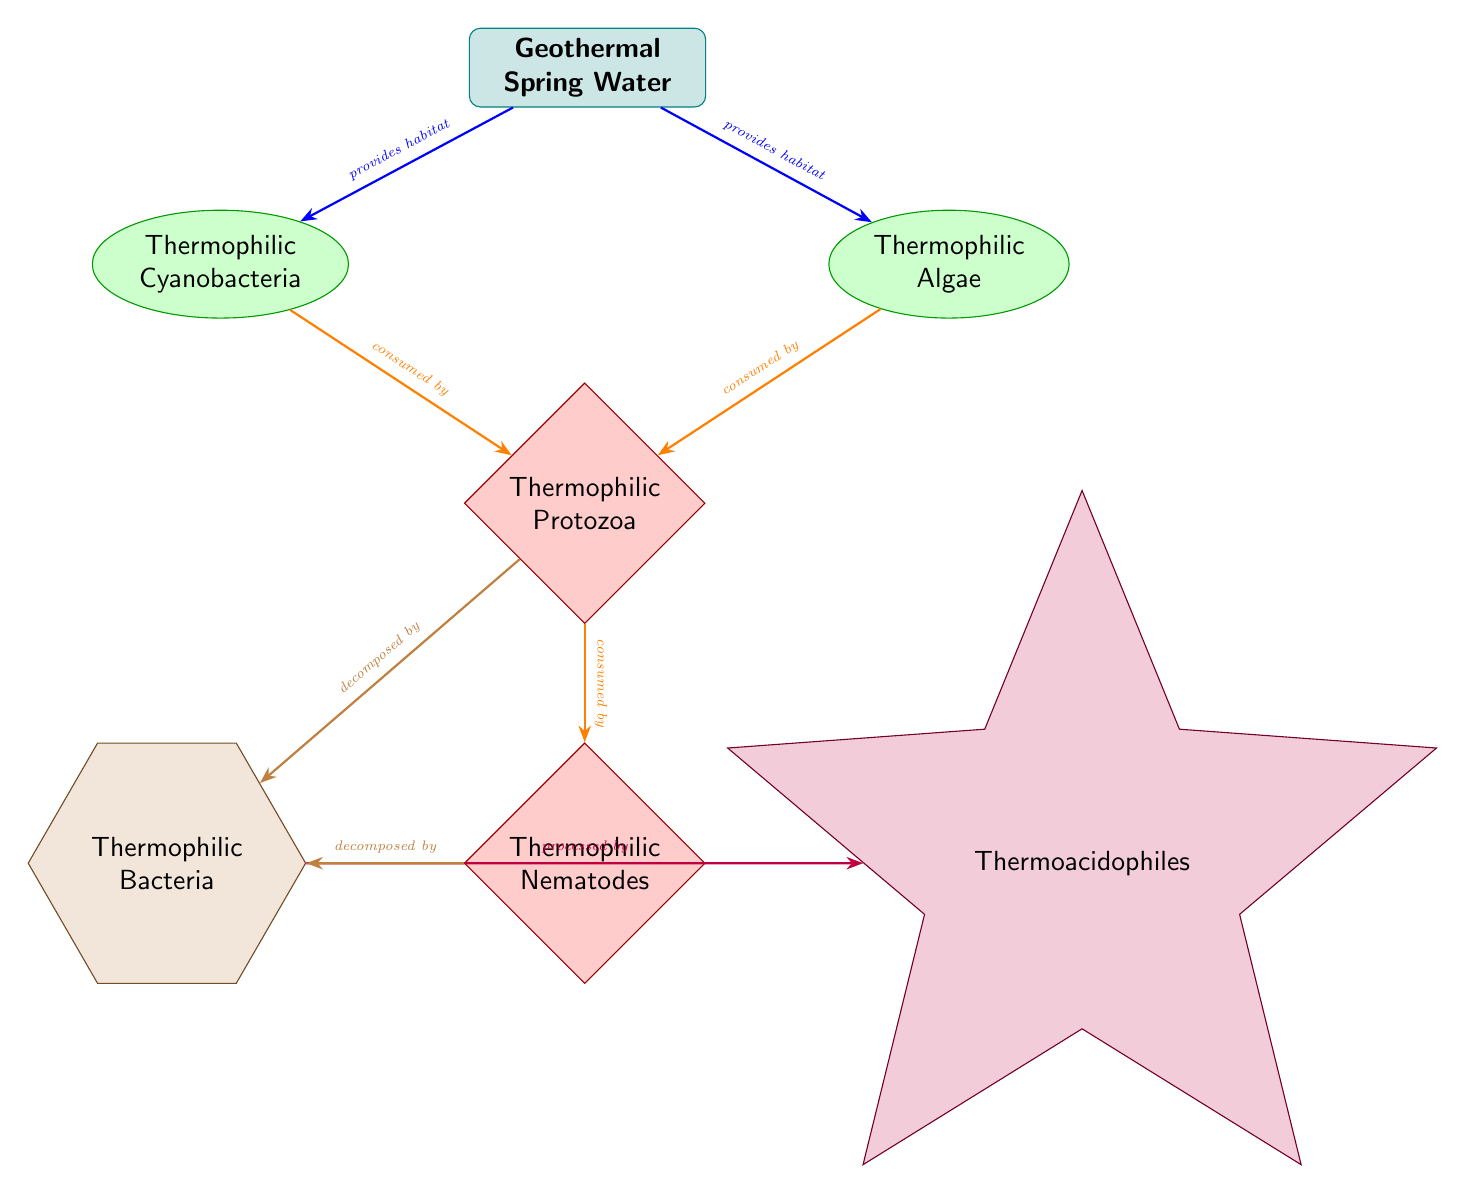What are the producers in this food web? The diagram identifies two producers: Thermophilic Cyanobacteria and Thermophilic Algae, which are shown as ellipses.
Answer: Thermophilic Cyanobacteria, Thermophilic Algae How many consumers are present in the food web? The food web contains two consumer nodes: Thermophilic Protozoa and Thermophilic Nematodes, which are represented as diamonds.
Answer: 2 What does the geothermal spring water provide for both producers? The arrows indicate that the geothermal spring water provides habitat for both producers: Thermophilic Cyanobacteria and Thermophilic Algae.
Answer: habitat Which organism decomposes both Thermophilic Protozoa and Thermophilic Nematodes? The diagram shows that Thermophilic Bacteria is the decomposer that breaks down both Thermophilic Protozoa and Thermophilic Nematodes, indicated by the relationships illustrated with brown arrows.
Answer: Thermophilic Bacteria What is the relationship between Thermophilic Protozoa and Thermophilic Nematodes? The diagram indicates that Thermophilic Protozoa are consumed by Thermophilic Nematodes, as shown by the orange arrow connecting them.
Answer: consumed by How is Thermophilic Bacteria processed in this food web? According to the diagram, Thermophilic Bacteria is processed by Thermoacidophiles, as indicated by the purple arrow leading from Thermophilic Bacteria to Thermoacidophiles.
Answer: processed by What type of bacteria is involved in decomposing the consumers? The food web specifies that Thermophilic Bacteria, shown as a regular polygon, is responsible for decomposing both Thermophilic Protozoa and Thermophilic Nematodes.
Answer: Thermophilic Bacteria Which node is located above the Thermophilic Protozoa in the diagram? The Thermophilic Cyanobacteria and Thermophilic Algae nodes are positioned above Thermophilic Protozoa, as they are both producers in the food web.
Answer: Thermophilic Cyanobacteria, Thermophilic Algae What role do Thermophilic Cyanobacteria and Thermophilic Algae play in this food web? In this food web, Thermophilic Cyanobacteria and Thermophilic Algae serve as producers, meaning they create energy for the ecosystem, primarily through photosynthesis or chemosynthesis in the geothermal spring.
Answer: producers 